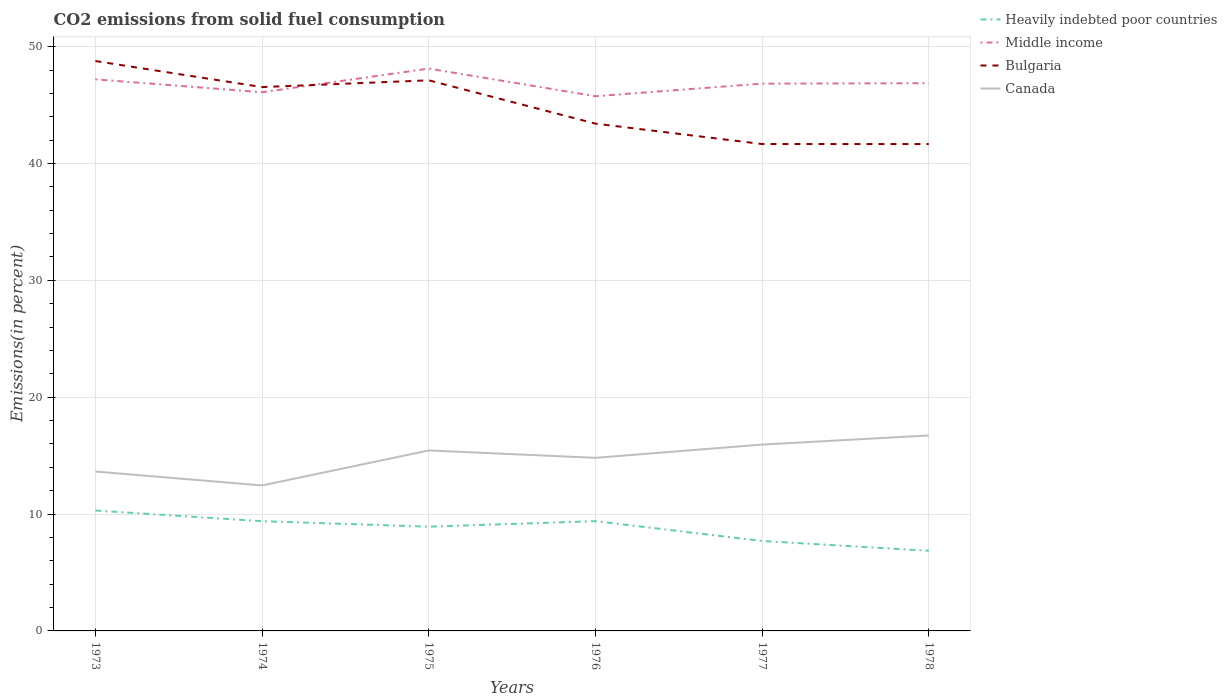How many different coloured lines are there?
Provide a succinct answer. 4. Does the line corresponding to Bulgaria intersect with the line corresponding to Canada?
Offer a very short reply. No. Is the number of lines equal to the number of legend labels?
Provide a succinct answer. Yes. Across all years, what is the maximum total CO2 emitted in Canada?
Offer a terse response. 12.45. In which year was the total CO2 emitted in Heavily indebted poor countries maximum?
Provide a short and direct response. 1978. What is the total total CO2 emitted in Bulgaria in the graph?
Make the answer very short. 5.35. What is the difference between the highest and the second highest total CO2 emitted in Canada?
Give a very brief answer. 4.28. How many years are there in the graph?
Ensure brevity in your answer.  6. What is the difference between two consecutive major ticks on the Y-axis?
Give a very brief answer. 10. Are the values on the major ticks of Y-axis written in scientific E-notation?
Keep it short and to the point. No. How many legend labels are there?
Offer a terse response. 4. How are the legend labels stacked?
Offer a very short reply. Vertical. What is the title of the graph?
Ensure brevity in your answer.  CO2 emissions from solid fuel consumption. Does "Thailand" appear as one of the legend labels in the graph?
Your response must be concise. No. What is the label or title of the Y-axis?
Provide a short and direct response. Emissions(in percent). What is the Emissions(in percent) in Heavily indebted poor countries in 1973?
Provide a succinct answer. 10.31. What is the Emissions(in percent) in Middle income in 1973?
Offer a very short reply. 47.2. What is the Emissions(in percent) in Bulgaria in 1973?
Keep it short and to the point. 48.77. What is the Emissions(in percent) of Canada in 1973?
Ensure brevity in your answer.  13.64. What is the Emissions(in percent) in Heavily indebted poor countries in 1974?
Your answer should be very brief. 9.39. What is the Emissions(in percent) of Middle income in 1974?
Make the answer very short. 46.1. What is the Emissions(in percent) in Bulgaria in 1974?
Your response must be concise. 46.54. What is the Emissions(in percent) of Canada in 1974?
Make the answer very short. 12.45. What is the Emissions(in percent) of Heavily indebted poor countries in 1975?
Provide a short and direct response. 8.92. What is the Emissions(in percent) in Middle income in 1975?
Provide a succinct answer. 48.12. What is the Emissions(in percent) in Bulgaria in 1975?
Keep it short and to the point. 47.12. What is the Emissions(in percent) in Canada in 1975?
Keep it short and to the point. 15.44. What is the Emissions(in percent) in Heavily indebted poor countries in 1976?
Your answer should be compact. 9.39. What is the Emissions(in percent) of Middle income in 1976?
Provide a short and direct response. 45.76. What is the Emissions(in percent) of Bulgaria in 1976?
Ensure brevity in your answer.  43.41. What is the Emissions(in percent) of Canada in 1976?
Offer a terse response. 14.81. What is the Emissions(in percent) of Heavily indebted poor countries in 1977?
Ensure brevity in your answer.  7.7. What is the Emissions(in percent) in Middle income in 1977?
Offer a very short reply. 46.83. What is the Emissions(in percent) of Bulgaria in 1977?
Your answer should be very brief. 41.67. What is the Emissions(in percent) in Canada in 1977?
Keep it short and to the point. 15.95. What is the Emissions(in percent) in Heavily indebted poor countries in 1978?
Provide a short and direct response. 6.86. What is the Emissions(in percent) in Middle income in 1978?
Provide a short and direct response. 46.87. What is the Emissions(in percent) in Bulgaria in 1978?
Your answer should be very brief. 41.66. What is the Emissions(in percent) of Canada in 1978?
Provide a short and direct response. 16.73. Across all years, what is the maximum Emissions(in percent) in Heavily indebted poor countries?
Ensure brevity in your answer.  10.31. Across all years, what is the maximum Emissions(in percent) of Middle income?
Make the answer very short. 48.12. Across all years, what is the maximum Emissions(in percent) of Bulgaria?
Ensure brevity in your answer.  48.77. Across all years, what is the maximum Emissions(in percent) of Canada?
Provide a succinct answer. 16.73. Across all years, what is the minimum Emissions(in percent) in Heavily indebted poor countries?
Your answer should be compact. 6.86. Across all years, what is the minimum Emissions(in percent) in Middle income?
Provide a short and direct response. 45.76. Across all years, what is the minimum Emissions(in percent) of Bulgaria?
Give a very brief answer. 41.66. Across all years, what is the minimum Emissions(in percent) of Canada?
Your response must be concise. 12.45. What is the total Emissions(in percent) in Heavily indebted poor countries in the graph?
Your response must be concise. 52.57. What is the total Emissions(in percent) of Middle income in the graph?
Make the answer very short. 280.89. What is the total Emissions(in percent) in Bulgaria in the graph?
Offer a very short reply. 269.17. What is the total Emissions(in percent) of Canada in the graph?
Offer a terse response. 89.02. What is the difference between the Emissions(in percent) in Heavily indebted poor countries in 1973 and that in 1974?
Your answer should be compact. 0.91. What is the difference between the Emissions(in percent) in Middle income in 1973 and that in 1974?
Make the answer very short. 1.1. What is the difference between the Emissions(in percent) of Bulgaria in 1973 and that in 1974?
Offer a very short reply. 2.23. What is the difference between the Emissions(in percent) in Canada in 1973 and that in 1974?
Make the answer very short. 1.19. What is the difference between the Emissions(in percent) in Heavily indebted poor countries in 1973 and that in 1975?
Offer a very short reply. 1.38. What is the difference between the Emissions(in percent) in Middle income in 1973 and that in 1975?
Make the answer very short. -0.92. What is the difference between the Emissions(in percent) in Bulgaria in 1973 and that in 1975?
Give a very brief answer. 1.65. What is the difference between the Emissions(in percent) of Canada in 1973 and that in 1975?
Provide a short and direct response. -1.8. What is the difference between the Emissions(in percent) of Heavily indebted poor countries in 1973 and that in 1976?
Provide a succinct answer. 0.91. What is the difference between the Emissions(in percent) of Middle income in 1973 and that in 1976?
Your response must be concise. 1.44. What is the difference between the Emissions(in percent) in Bulgaria in 1973 and that in 1976?
Offer a terse response. 5.35. What is the difference between the Emissions(in percent) of Canada in 1973 and that in 1976?
Your answer should be very brief. -1.17. What is the difference between the Emissions(in percent) of Heavily indebted poor countries in 1973 and that in 1977?
Provide a short and direct response. 2.61. What is the difference between the Emissions(in percent) in Middle income in 1973 and that in 1977?
Offer a terse response. 0.37. What is the difference between the Emissions(in percent) in Bulgaria in 1973 and that in 1977?
Give a very brief answer. 7.1. What is the difference between the Emissions(in percent) of Canada in 1973 and that in 1977?
Provide a short and direct response. -2.31. What is the difference between the Emissions(in percent) of Heavily indebted poor countries in 1973 and that in 1978?
Provide a short and direct response. 3.45. What is the difference between the Emissions(in percent) in Middle income in 1973 and that in 1978?
Keep it short and to the point. 0.33. What is the difference between the Emissions(in percent) of Bulgaria in 1973 and that in 1978?
Make the answer very short. 7.1. What is the difference between the Emissions(in percent) in Canada in 1973 and that in 1978?
Ensure brevity in your answer.  -3.09. What is the difference between the Emissions(in percent) in Heavily indebted poor countries in 1974 and that in 1975?
Keep it short and to the point. 0.47. What is the difference between the Emissions(in percent) of Middle income in 1974 and that in 1975?
Give a very brief answer. -2.02. What is the difference between the Emissions(in percent) of Bulgaria in 1974 and that in 1975?
Ensure brevity in your answer.  -0.58. What is the difference between the Emissions(in percent) of Canada in 1974 and that in 1975?
Your answer should be very brief. -2.99. What is the difference between the Emissions(in percent) in Heavily indebted poor countries in 1974 and that in 1976?
Your answer should be compact. -0. What is the difference between the Emissions(in percent) in Middle income in 1974 and that in 1976?
Keep it short and to the point. 0.34. What is the difference between the Emissions(in percent) of Bulgaria in 1974 and that in 1976?
Ensure brevity in your answer.  3.13. What is the difference between the Emissions(in percent) of Canada in 1974 and that in 1976?
Make the answer very short. -2.36. What is the difference between the Emissions(in percent) in Heavily indebted poor countries in 1974 and that in 1977?
Provide a succinct answer. 1.69. What is the difference between the Emissions(in percent) in Middle income in 1974 and that in 1977?
Keep it short and to the point. -0.74. What is the difference between the Emissions(in percent) of Bulgaria in 1974 and that in 1977?
Offer a terse response. 4.87. What is the difference between the Emissions(in percent) in Canada in 1974 and that in 1977?
Keep it short and to the point. -3.5. What is the difference between the Emissions(in percent) in Heavily indebted poor countries in 1974 and that in 1978?
Provide a succinct answer. 2.53. What is the difference between the Emissions(in percent) of Middle income in 1974 and that in 1978?
Offer a very short reply. -0.77. What is the difference between the Emissions(in percent) in Bulgaria in 1974 and that in 1978?
Make the answer very short. 4.87. What is the difference between the Emissions(in percent) in Canada in 1974 and that in 1978?
Provide a short and direct response. -4.28. What is the difference between the Emissions(in percent) of Heavily indebted poor countries in 1975 and that in 1976?
Give a very brief answer. -0.47. What is the difference between the Emissions(in percent) in Middle income in 1975 and that in 1976?
Make the answer very short. 2.37. What is the difference between the Emissions(in percent) of Bulgaria in 1975 and that in 1976?
Offer a very short reply. 3.71. What is the difference between the Emissions(in percent) of Canada in 1975 and that in 1976?
Keep it short and to the point. 0.63. What is the difference between the Emissions(in percent) in Heavily indebted poor countries in 1975 and that in 1977?
Keep it short and to the point. 1.22. What is the difference between the Emissions(in percent) in Middle income in 1975 and that in 1977?
Your answer should be compact. 1.29. What is the difference between the Emissions(in percent) of Bulgaria in 1975 and that in 1977?
Give a very brief answer. 5.45. What is the difference between the Emissions(in percent) of Canada in 1975 and that in 1977?
Keep it short and to the point. -0.5. What is the difference between the Emissions(in percent) in Heavily indebted poor countries in 1975 and that in 1978?
Provide a succinct answer. 2.06. What is the difference between the Emissions(in percent) of Middle income in 1975 and that in 1978?
Your response must be concise. 1.25. What is the difference between the Emissions(in percent) in Bulgaria in 1975 and that in 1978?
Offer a very short reply. 5.45. What is the difference between the Emissions(in percent) in Canada in 1975 and that in 1978?
Give a very brief answer. -1.28. What is the difference between the Emissions(in percent) in Heavily indebted poor countries in 1976 and that in 1977?
Offer a very short reply. 1.7. What is the difference between the Emissions(in percent) of Middle income in 1976 and that in 1977?
Your answer should be very brief. -1.08. What is the difference between the Emissions(in percent) of Bulgaria in 1976 and that in 1977?
Your response must be concise. 1.75. What is the difference between the Emissions(in percent) in Canada in 1976 and that in 1977?
Offer a terse response. -1.13. What is the difference between the Emissions(in percent) of Heavily indebted poor countries in 1976 and that in 1978?
Offer a very short reply. 2.54. What is the difference between the Emissions(in percent) in Middle income in 1976 and that in 1978?
Your answer should be very brief. -1.11. What is the difference between the Emissions(in percent) of Bulgaria in 1976 and that in 1978?
Make the answer very short. 1.75. What is the difference between the Emissions(in percent) of Canada in 1976 and that in 1978?
Provide a short and direct response. -1.91. What is the difference between the Emissions(in percent) in Heavily indebted poor countries in 1977 and that in 1978?
Your answer should be compact. 0.84. What is the difference between the Emissions(in percent) of Middle income in 1977 and that in 1978?
Your answer should be very brief. -0.04. What is the difference between the Emissions(in percent) of Bulgaria in 1977 and that in 1978?
Keep it short and to the point. 0. What is the difference between the Emissions(in percent) of Canada in 1977 and that in 1978?
Your response must be concise. -0.78. What is the difference between the Emissions(in percent) of Heavily indebted poor countries in 1973 and the Emissions(in percent) of Middle income in 1974?
Give a very brief answer. -35.79. What is the difference between the Emissions(in percent) of Heavily indebted poor countries in 1973 and the Emissions(in percent) of Bulgaria in 1974?
Keep it short and to the point. -36.23. What is the difference between the Emissions(in percent) of Heavily indebted poor countries in 1973 and the Emissions(in percent) of Canada in 1974?
Provide a succinct answer. -2.14. What is the difference between the Emissions(in percent) of Middle income in 1973 and the Emissions(in percent) of Bulgaria in 1974?
Keep it short and to the point. 0.66. What is the difference between the Emissions(in percent) of Middle income in 1973 and the Emissions(in percent) of Canada in 1974?
Your answer should be very brief. 34.75. What is the difference between the Emissions(in percent) in Bulgaria in 1973 and the Emissions(in percent) in Canada in 1974?
Keep it short and to the point. 36.32. What is the difference between the Emissions(in percent) in Heavily indebted poor countries in 1973 and the Emissions(in percent) in Middle income in 1975?
Offer a terse response. -37.82. What is the difference between the Emissions(in percent) of Heavily indebted poor countries in 1973 and the Emissions(in percent) of Bulgaria in 1975?
Your response must be concise. -36.81. What is the difference between the Emissions(in percent) of Heavily indebted poor countries in 1973 and the Emissions(in percent) of Canada in 1975?
Provide a succinct answer. -5.14. What is the difference between the Emissions(in percent) of Middle income in 1973 and the Emissions(in percent) of Bulgaria in 1975?
Provide a succinct answer. 0.08. What is the difference between the Emissions(in percent) of Middle income in 1973 and the Emissions(in percent) of Canada in 1975?
Your answer should be compact. 31.76. What is the difference between the Emissions(in percent) in Bulgaria in 1973 and the Emissions(in percent) in Canada in 1975?
Give a very brief answer. 33.32. What is the difference between the Emissions(in percent) in Heavily indebted poor countries in 1973 and the Emissions(in percent) in Middle income in 1976?
Offer a very short reply. -35.45. What is the difference between the Emissions(in percent) in Heavily indebted poor countries in 1973 and the Emissions(in percent) in Bulgaria in 1976?
Provide a short and direct response. -33.11. What is the difference between the Emissions(in percent) in Heavily indebted poor countries in 1973 and the Emissions(in percent) in Canada in 1976?
Make the answer very short. -4.51. What is the difference between the Emissions(in percent) in Middle income in 1973 and the Emissions(in percent) in Bulgaria in 1976?
Keep it short and to the point. 3.79. What is the difference between the Emissions(in percent) of Middle income in 1973 and the Emissions(in percent) of Canada in 1976?
Offer a very short reply. 32.39. What is the difference between the Emissions(in percent) of Bulgaria in 1973 and the Emissions(in percent) of Canada in 1976?
Offer a very short reply. 33.95. What is the difference between the Emissions(in percent) in Heavily indebted poor countries in 1973 and the Emissions(in percent) in Middle income in 1977?
Provide a succinct answer. -36.53. What is the difference between the Emissions(in percent) of Heavily indebted poor countries in 1973 and the Emissions(in percent) of Bulgaria in 1977?
Ensure brevity in your answer.  -31.36. What is the difference between the Emissions(in percent) in Heavily indebted poor countries in 1973 and the Emissions(in percent) in Canada in 1977?
Your answer should be very brief. -5.64. What is the difference between the Emissions(in percent) of Middle income in 1973 and the Emissions(in percent) of Bulgaria in 1977?
Provide a short and direct response. 5.54. What is the difference between the Emissions(in percent) in Middle income in 1973 and the Emissions(in percent) in Canada in 1977?
Keep it short and to the point. 31.26. What is the difference between the Emissions(in percent) in Bulgaria in 1973 and the Emissions(in percent) in Canada in 1977?
Offer a terse response. 32.82. What is the difference between the Emissions(in percent) in Heavily indebted poor countries in 1973 and the Emissions(in percent) in Middle income in 1978?
Keep it short and to the point. -36.57. What is the difference between the Emissions(in percent) in Heavily indebted poor countries in 1973 and the Emissions(in percent) in Bulgaria in 1978?
Make the answer very short. -31.36. What is the difference between the Emissions(in percent) in Heavily indebted poor countries in 1973 and the Emissions(in percent) in Canada in 1978?
Offer a terse response. -6.42. What is the difference between the Emissions(in percent) of Middle income in 1973 and the Emissions(in percent) of Bulgaria in 1978?
Make the answer very short. 5.54. What is the difference between the Emissions(in percent) in Middle income in 1973 and the Emissions(in percent) in Canada in 1978?
Your answer should be compact. 30.48. What is the difference between the Emissions(in percent) of Bulgaria in 1973 and the Emissions(in percent) of Canada in 1978?
Your response must be concise. 32.04. What is the difference between the Emissions(in percent) in Heavily indebted poor countries in 1974 and the Emissions(in percent) in Middle income in 1975?
Offer a terse response. -38.73. What is the difference between the Emissions(in percent) in Heavily indebted poor countries in 1974 and the Emissions(in percent) in Bulgaria in 1975?
Your answer should be compact. -37.73. What is the difference between the Emissions(in percent) of Heavily indebted poor countries in 1974 and the Emissions(in percent) of Canada in 1975?
Provide a succinct answer. -6.05. What is the difference between the Emissions(in percent) of Middle income in 1974 and the Emissions(in percent) of Bulgaria in 1975?
Provide a succinct answer. -1.02. What is the difference between the Emissions(in percent) in Middle income in 1974 and the Emissions(in percent) in Canada in 1975?
Ensure brevity in your answer.  30.66. What is the difference between the Emissions(in percent) in Bulgaria in 1974 and the Emissions(in percent) in Canada in 1975?
Your answer should be compact. 31.1. What is the difference between the Emissions(in percent) of Heavily indebted poor countries in 1974 and the Emissions(in percent) of Middle income in 1976?
Your answer should be compact. -36.37. What is the difference between the Emissions(in percent) in Heavily indebted poor countries in 1974 and the Emissions(in percent) in Bulgaria in 1976?
Your response must be concise. -34.02. What is the difference between the Emissions(in percent) in Heavily indebted poor countries in 1974 and the Emissions(in percent) in Canada in 1976?
Give a very brief answer. -5.42. What is the difference between the Emissions(in percent) in Middle income in 1974 and the Emissions(in percent) in Bulgaria in 1976?
Your response must be concise. 2.69. What is the difference between the Emissions(in percent) in Middle income in 1974 and the Emissions(in percent) in Canada in 1976?
Your response must be concise. 31.29. What is the difference between the Emissions(in percent) of Bulgaria in 1974 and the Emissions(in percent) of Canada in 1976?
Offer a terse response. 31.73. What is the difference between the Emissions(in percent) of Heavily indebted poor countries in 1974 and the Emissions(in percent) of Middle income in 1977?
Provide a succinct answer. -37.44. What is the difference between the Emissions(in percent) of Heavily indebted poor countries in 1974 and the Emissions(in percent) of Bulgaria in 1977?
Your answer should be very brief. -32.28. What is the difference between the Emissions(in percent) of Heavily indebted poor countries in 1974 and the Emissions(in percent) of Canada in 1977?
Your answer should be very brief. -6.56. What is the difference between the Emissions(in percent) in Middle income in 1974 and the Emissions(in percent) in Bulgaria in 1977?
Your response must be concise. 4.43. What is the difference between the Emissions(in percent) in Middle income in 1974 and the Emissions(in percent) in Canada in 1977?
Provide a succinct answer. 30.15. What is the difference between the Emissions(in percent) of Bulgaria in 1974 and the Emissions(in percent) of Canada in 1977?
Offer a terse response. 30.59. What is the difference between the Emissions(in percent) of Heavily indebted poor countries in 1974 and the Emissions(in percent) of Middle income in 1978?
Offer a very short reply. -37.48. What is the difference between the Emissions(in percent) in Heavily indebted poor countries in 1974 and the Emissions(in percent) in Bulgaria in 1978?
Give a very brief answer. -32.27. What is the difference between the Emissions(in percent) of Heavily indebted poor countries in 1974 and the Emissions(in percent) of Canada in 1978?
Provide a succinct answer. -7.34. What is the difference between the Emissions(in percent) of Middle income in 1974 and the Emissions(in percent) of Bulgaria in 1978?
Offer a very short reply. 4.43. What is the difference between the Emissions(in percent) of Middle income in 1974 and the Emissions(in percent) of Canada in 1978?
Provide a short and direct response. 29.37. What is the difference between the Emissions(in percent) in Bulgaria in 1974 and the Emissions(in percent) in Canada in 1978?
Your answer should be compact. 29.81. What is the difference between the Emissions(in percent) of Heavily indebted poor countries in 1975 and the Emissions(in percent) of Middle income in 1976?
Your response must be concise. -36.84. What is the difference between the Emissions(in percent) in Heavily indebted poor countries in 1975 and the Emissions(in percent) in Bulgaria in 1976?
Offer a very short reply. -34.49. What is the difference between the Emissions(in percent) of Heavily indebted poor countries in 1975 and the Emissions(in percent) of Canada in 1976?
Give a very brief answer. -5.89. What is the difference between the Emissions(in percent) of Middle income in 1975 and the Emissions(in percent) of Bulgaria in 1976?
Your answer should be very brief. 4.71. What is the difference between the Emissions(in percent) of Middle income in 1975 and the Emissions(in percent) of Canada in 1976?
Your response must be concise. 33.31. What is the difference between the Emissions(in percent) in Bulgaria in 1975 and the Emissions(in percent) in Canada in 1976?
Provide a succinct answer. 32.31. What is the difference between the Emissions(in percent) of Heavily indebted poor countries in 1975 and the Emissions(in percent) of Middle income in 1977?
Offer a very short reply. -37.91. What is the difference between the Emissions(in percent) in Heavily indebted poor countries in 1975 and the Emissions(in percent) in Bulgaria in 1977?
Offer a terse response. -32.74. What is the difference between the Emissions(in percent) of Heavily indebted poor countries in 1975 and the Emissions(in percent) of Canada in 1977?
Offer a terse response. -7.03. What is the difference between the Emissions(in percent) of Middle income in 1975 and the Emissions(in percent) of Bulgaria in 1977?
Provide a short and direct response. 6.46. What is the difference between the Emissions(in percent) in Middle income in 1975 and the Emissions(in percent) in Canada in 1977?
Offer a terse response. 32.18. What is the difference between the Emissions(in percent) of Bulgaria in 1975 and the Emissions(in percent) of Canada in 1977?
Keep it short and to the point. 31.17. What is the difference between the Emissions(in percent) of Heavily indebted poor countries in 1975 and the Emissions(in percent) of Middle income in 1978?
Make the answer very short. -37.95. What is the difference between the Emissions(in percent) in Heavily indebted poor countries in 1975 and the Emissions(in percent) in Bulgaria in 1978?
Your answer should be compact. -32.74. What is the difference between the Emissions(in percent) in Heavily indebted poor countries in 1975 and the Emissions(in percent) in Canada in 1978?
Give a very brief answer. -7.81. What is the difference between the Emissions(in percent) of Middle income in 1975 and the Emissions(in percent) of Bulgaria in 1978?
Your response must be concise. 6.46. What is the difference between the Emissions(in percent) of Middle income in 1975 and the Emissions(in percent) of Canada in 1978?
Your response must be concise. 31.4. What is the difference between the Emissions(in percent) in Bulgaria in 1975 and the Emissions(in percent) in Canada in 1978?
Offer a very short reply. 30.39. What is the difference between the Emissions(in percent) in Heavily indebted poor countries in 1976 and the Emissions(in percent) in Middle income in 1977?
Make the answer very short. -37.44. What is the difference between the Emissions(in percent) of Heavily indebted poor countries in 1976 and the Emissions(in percent) of Bulgaria in 1977?
Provide a succinct answer. -32.27. What is the difference between the Emissions(in percent) in Heavily indebted poor countries in 1976 and the Emissions(in percent) in Canada in 1977?
Keep it short and to the point. -6.55. What is the difference between the Emissions(in percent) of Middle income in 1976 and the Emissions(in percent) of Bulgaria in 1977?
Offer a terse response. 4.09. What is the difference between the Emissions(in percent) in Middle income in 1976 and the Emissions(in percent) in Canada in 1977?
Your answer should be compact. 29.81. What is the difference between the Emissions(in percent) of Bulgaria in 1976 and the Emissions(in percent) of Canada in 1977?
Your response must be concise. 27.47. What is the difference between the Emissions(in percent) of Heavily indebted poor countries in 1976 and the Emissions(in percent) of Middle income in 1978?
Ensure brevity in your answer.  -37.48. What is the difference between the Emissions(in percent) in Heavily indebted poor countries in 1976 and the Emissions(in percent) in Bulgaria in 1978?
Your answer should be very brief. -32.27. What is the difference between the Emissions(in percent) in Heavily indebted poor countries in 1976 and the Emissions(in percent) in Canada in 1978?
Your answer should be compact. -7.33. What is the difference between the Emissions(in percent) in Middle income in 1976 and the Emissions(in percent) in Bulgaria in 1978?
Ensure brevity in your answer.  4.09. What is the difference between the Emissions(in percent) of Middle income in 1976 and the Emissions(in percent) of Canada in 1978?
Provide a succinct answer. 29.03. What is the difference between the Emissions(in percent) of Bulgaria in 1976 and the Emissions(in percent) of Canada in 1978?
Your response must be concise. 26.69. What is the difference between the Emissions(in percent) of Heavily indebted poor countries in 1977 and the Emissions(in percent) of Middle income in 1978?
Your response must be concise. -39.17. What is the difference between the Emissions(in percent) of Heavily indebted poor countries in 1977 and the Emissions(in percent) of Bulgaria in 1978?
Keep it short and to the point. -33.97. What is the difference between the Emissions(in percent) in Heavily indebted poor countries in 1977 and the Emissions(in percent) in Canada in 1978?
Give a very brief answer. -9.03. What is the difference between the Emissions(in percent) in Middle income in 1977 and the Emissions(in percent) in Bulgaria in 1978?
Keep it short and to the point. 5.17. What is the difference between the Emissions(in percent) of Middle income in 1977 and the Emissions(in percent) of Canada in 1978?
Provide a succinct answer. 30.11. What is the difference between the Emissions(in percent) in Bulgaria in 1977 and the Emissions(in percent) in Canada in 1978?
Keep it short and to the point. 24.94. What is the average Emissions(in percent) in Heavily indebted poor countries per year?
Your answer should be compact. 8.76. What is the average Emissions(in percent) in Middle income per year?
Offer a terse response. 46.81. What is the average Emissions(in percent) of Bulgaria per year?
Give a very brief answer. 44.86. What is the average Emissions(in percent) of Canada per year?
Offer a very short reply. 14.84. In the year 1973, what is the difference between the Emissions(in percent) of Heavily indebted poor countries and Emissions(in percent) of Middle income?
Offer a very short reply. -36.9. In the year 1973, what is the difference between the Emissions(in percent) of Heavily indebted poor countries and Emissions(in percent) of Bulgaria?
Provide a short and direct response. -38.46. In the year 1973, what is the difference between the Emissions(in percent) of Heavily indebted poor countries and Emissions(in percent) of Canada?
Offer a terse response. -3.34. In the year 1973, what is the difference between the Emissions(in percent) in Middle income and Emissions(in percent) in Bulgaria?
Your answer should be compact. -1.56. In the year 1973, what is the difference between the Emissions(in percent) of Middle income and Emissions(in percent) of Canada?
Keep it short and to the point. 33.56. In the year 1973, what is the difference between the Emissions(in percent) in Bulgaria and Emissions(in percent) in Canada?
Make the answer very short. 35.13. In the year 1974, what is the difference between the Emissions(in percent) in Heavily indebted poor countries and Emissions(in percent) in Middle income?
Provide a succinct answer. -36.71. In the year 1974, what is the difference between the Emissions(in percent) in Heavily indebted poor countries and Emissions(in percent) in Bulgaria?
Offer a very short reply. -37.15. In the year 1974, what is the difference between the Emissions(in percent) of Heavily indebted poor countries and Emissions(in percent) of Canada?
Your answer should be compact. -3.06. In the year 1974, what is the difference between the Emissions(in percent) of Middle income and Emissions(in percent) of Bulgaria?
Give a very brief answer. -0.44. In the year 1974, what is the difference between the Emissions(in percent) of Middle income and Emissions(in percent) of Canada?
Give a very brief answer. 33.65. In the year 1974, what is the difference between the Emissions(in percent) of Bulgaria and Emissions(in percent) of Canada?
Keep it short and to the point. 34.09. In the year 1975, what is the difference between the Emissions(in percent) in Heavily indebted poor countries and Emissions(in percent) in Middle income?
Offer a terse response. -39.2. In the year 1975, what is the difference between the Emissions(in percent) in Heavily indebted poor countries and Emissions(in percent) in Bulgaria?
Give a very brief answer. -38.2. In the year 1975, what is the difference between the Emissions(in percent) in Heavily indebted poor countries and Emissions(in percent) in Canada?
Ensure brevity in your answer.  -6.52. In the year 1975, what is the difference between the Emissions(in percent) of Middle income and Emissions(in percent) of Bulgaria?
Ensure brevity in your answer.  1. In the year 1975, what is the difference between the Emissions(in percent) of Middle income and Emissions(in percent) of Canada?
Your answer should be compact. 32.68. In the year 1975, what is the difference between the Emissions(in percent) in Bulgaria and Emissions(in percent) in Canada?
Offer a very short reply. 31.68. In the year 1976, what is the difference between the Emissions(in percent) in Heavily indebted poor countries and Emissions(in percent) in Middle income?
Your response must be concise. -36.36. In the year 1976, what is the difference between the Emissions(in percent) in Heavily indebted poor countries and Emissions(in percent) in Bulgaria?
Offer a very short reply. -34.02. In the year 1976, what is the difference between the Emissions(in percent) in Heavily indebted poor countries and Emissions(in percent) in Canada?
Ensure brevity in your answer.  -5.42. In the year 1976, what is the difference between the Emissions(in percent) in Middle income and Emissions(in percent) in Bulgaria?
Ensure brevity in your answer.  2.35. In the year 1976, what is the difference between the Emissions(in percent) of Middle income and Emissions(in percent) of Canada?
Provide a succinct answer. 30.95. In the year 1976, what is the difference between the Emissions(in percent) in Bulgaria and Emissions(in percent) in Canada?
Give a very brief answer. 28.6. In the year 1977, what is the difference between the Emissions(in percent) in Heavily indebted poor countries and Emissions(in percent) in Middle income?
Provide a short and direct response. -39.14. In the year 1977, what is the difference between the Emissions(in percent) in Heavily indebted poor countries and Emissions(in percent) in Bulgaria?
Offer a terse response. -33.97. In the year 1977, what is the difference between the Emissions(in percent) of Heavily indebted poor countries and Emissions(in percent) of Canada?
Keep it short and to the point. -8.25. In the year 1977, what is the difference between the Emissions(in percent) in Middle income and Emissions(in percent) in Bulgaria?
Provide a succinct answer. 5.17. In the year 1977, what is the difference between the Emissions(in percent) of Middle income and Emissions(in percent) of Canada?
Provide a short and direct response. 30.89. In the year 1977, what is the difference between the Emissions(in percent) in Bulgaria and Emissions(in percent) in Canada?
Provide a succinct answer. 25.72. In the year 1978, what is the difference between the Emissions(in percent) of Heavily indebted poor countries and Emissions(in percent) of Middle income?
Keep it short and to the point. -40.01. In the year 1978, what is the difference between the Emissions(in percent) in Heavily indebted poor countries and Emissions(in percent) in Bulgaria?
Offer a very short reply. -34.81. In the year 1978, what is the difference between the Emissions(in percent) of Heavily indebted poor countries and Emissions(in percent) of Canada?
Your response must be concise. -9.87. In the year 1978, what is the difference between the Emissions(in percent) in Middle income and Emissions(in percent) in Bulgaria?
Keep it short and to the point. 5.21. In the year 1978, what is the difference between the Emissions(in percent) of Middle income and Emissions(in percent) of Canada?
Give a very brief answer. 30.14. In the year 1978, what is the difference between the Emissions(in percent) of Bulgaria and Emissions(in percent) of Canada?
Make the answer very short. 24.94. What is the ratio of the Emissions(in percent) of Heavily indebted poor countries in 1973 to that in 1974?
Keep it short and to the point. 1.1. What is the ratio of the Emissions(in percent) in Middle income in 1973 to that in 1974?
Offer a very short reply. 1.02. What is the ratio of the Emissions(in percent) in Bulgaria in 1973 to that in 1974?
Keep it short and to the point. 1.05. What is the ratio of the Emissions(in percent) of Canada in 1973 to that in 1974?
Your answer should be compact. 1.1. What is the ratio of the Emissions(in percent) of Heavily indebted poor countries in 1973 to that in 1975?
Provide a succinct answer. 1.16. What is the ratio of the Emissions(in percent) in Middle income in 1973 to that in 1975?
Your response must be concise. 0.98. What is the ratio of the Emissions(in percent) in Bulgaria in 1973 to that in 1975?
Provide a short and direct response. 1.03. What is the ratio of the Emissions(in percent) in Canada in 1973 to that in 1975?
Provide a succinct answer. 0.88. What is the ratio of the Emissions(in percent) of Heavily indebted poor countries in 1973 to that in 1976?
Make the answer very short. 1.1. What is the ratio of the Emissions(in percent) in Middle income in 1973 to that in 1976?
Your answer should be very brief. 1.03. What is the ratio of the Emissions(in percent) in Bulgaria in 1973 to that in 1976?
Your answer should be compact. 1.12. What is the ratio of the Emissions(in percent) of Canada in 1973 to that in 1976?
Your answer should be compact. 0.92. What is the ratio of the Emissions(in percent) in Heavily indebted poor countries in 1973 to that in 1977?
Provide a short and direct response. 1.34. What is the ratio of the Emissions(in percent) in Middle income in 1973 to that in 1977?
Provide a short and direct response. 1.01. What is the ratio of the Emissions(in percent) in Bulgaria in 1973 to that in 1977?
Give a very brief answer. 1.17. What is the ratio of the Emissions(in percent) in Canada in 1973 to that in 1977?
Your answer should be compact. 0.86. What is the ratio of the Emissions(in percent) of Heavily indebted poor countries in 1973 to that in 1978?
Offer a terse response. 1.5. What is the ratio of the Emissions(in percent) of Middle income in 1973 to that in 1978?
Provide a succinct answer. 1.01. What is the ratio of the Emissions(in percent) of Bulgaria in 1973 to that in 1978?
Provide a short and direct response. 1.17. What is the ratio of the Emissions(in percent) of Canada in 1973 to that in 1978?
Provide a succinct answer. 0.82. What is the ratio of the Emissions(in percent) of Heavily indebted poor countries in 1974 to that in 1975?
Provide a short and direct response. 1.05. What is the ratio of the Emissions(in percent) in Middle income in 1974 to that in 1975?
Offer a very short reply. 0.96. What is the ratio of the Emissions(in percent) in Bulgaria in 1974 to that in 1975?
Your response must be concise. 0.99. What is the ratio of the Emissions(in percent) in Canada in 1974 to that in 1975?
Your answer should be very brief. 0.81. What is the ratio of the Emissions(in percent) in Heavily indebted poor countries in 1974 to that in 1976?
Ensure brevity in your answer.  1. What is the ratio of the Emissions(in percent) in Middle income in 1974 to that in 1976?
Ensure brevity in your answer.  1.01. What is the ratio of the Emissions(in percent) of Bulgaria in 1974 to that in 1976?
Offer a terse response. 1.07. What is the ratio of the Emissions(in percent) of Canada in 1974 to that in 1976?
Provide a succinct answer. 0.84. What is the ratio of the Emissions(in percent) in Heavily indebted poor countries in 1974 to that in 1977?
Your answer should be very brief. 1.22. What is the ratio of the Emissions(in percent) of Middle income in 1974 to that in 1977?
Make the answer very short. 0.98. What is the ratio of the Emissions(in percent) of Bulgaria in 1974 to that in 1977?
Your response must be concise. 1.12. What is the ratio of the Emissions(in percent) in Canada in 1974 to that in 1977?
Offer a terse response. 0.78. What is the ratio of the Emissions(in percent) of Heavily indebted poor countries in 1974 to that in 1978?
Give a very brief answer. 1.37. What is the ratio of the Emissions(in percent) in Middle income in 1974 to that in 1978?
Your response must be concise. 0.98. What is the ratio of the Emissions(in percent) in Bulgaria in 1974 to that in 1978?
Keep it short and to the point. 1.12. What is the ratio of the Emissions(in percent) of Canada in 1974 to that in 1978?
Give a very brief answer. 0.74. What is the ratio of the Emissions(in percent) in Heavily indebted poor countries in 1975 to that in 1976?
Give a very brief answer. 0.95. What is the ratio of the Emissions(in percent) of Middle income in 1975 to that in 1976?
Offer a terse response. 1.05. What is the ratio of the Emissions(in percent) of Bulgaria in 1975 to that in 1976?
Provide a short and direct response. 1.09. What is the ratio of the Emissions(in percent) in Canada in 1975 to that in 1976?
Give a very brief answer. 1.04. What is the ratio of the Emissions(in percent) in Heavily indebted poor countries in 1975 to that in 1977?
Keep it short and to the point. 1.16. What is the ratio of the Emissions(in percent) of Middle income in 1975 to that in 1977?
Provide a succinct answer. 1.03. What is the ratio of the Emissions(in percent) of Bulgaria in 1975 to that in 1977?
Make the answer very short. 1.13. What is the ratio of the Emissions(in percent) of Canada in 1975 to that in 1977?
Your answer should be very brief. 0.97. What is the ratio of the Emissions(in percent) in Heavily indebted poor countries in 1975 to that in 1978?
Provide a short and direct response. 1.3. What is the ratio of the Emissions(in percent) of Middle income in 1975 to that in 1978?
Provide a short and direct response. 1.03. What is the ratio of the Emissions(in percent) of Bulgaria in 1975 to that in 1978?
Your answer should be compact. 1.13. What is the ratio of the Emissions(in percent) of Canada in 1975 to that in 1978?
Offer a very short reply. 0.92. What is the ratio of the Emissions(in percent) of Heavily indebted poor countries in 1976 to that in 1977?
Ensure brevity in your answer.  1.22. What is the ratio of the Emissions(in percent) of Bulgaria in 1976 to that in 1977?
Offer a terse response. 1.04. What is the ratio of the Emissions(in percent) in Canada in 1976 to that in 1977?
Give a very brief answer. 0.93. What is the ratio of the Emissions(in percent) in Heavily indebted poor countries in 1976 to that in 1978?
Offer a very short reply. 1.37. What is the ratio of the Emissions(in percent) in Middle income in 1976 to that in 1978?
Your answer should be compact. 0.98. What is the ratio of the Emissions(in percent) of Bulgaria in 1976 to that in 1978?
Your answer should be compact. 1.04. What is the ratio of the Emissions(in percent) of Canada in 1976 to that in 1978?
Your response must be concise. 0.89. What is the ratio of the Emissions(in percent) of Heavily indebted poor countries in 1977 to that in 1978?
Ensure brevity in your answer.  1.12. What is the ratio of the Emissions(in percent) of Middle income in 1977 to that in 1978?
Ensure brevity in your answer.  1. What is the ratio of the Emissions(in percent) of Bulgaria in 1977 to that in 1978?
Provide a succinct answer. 1. What is the ratio of the Emissions(in percent) in Canada in 1977 to that in 1978?
Make the answer very short. 0.95. What is the difference between the highest and the second highest Emissions(in percent) in Heavily indebted poor countries?
Keep it short and to the point. 0.91. What is the difference between the highest and the second highest Emissions(in percent) of Middle income?
Keep it short and to the point. 0.92. What is the difference between the highest and the second highest Emissions(in percent) of Bulgaria?
Your answer should be very brief. 1.65. What is the difference between the highest and the second highest Emissions(in percent) of Canada?
Your response must be concise. 0.78. What is the difference between the highest and the lowest Emissions(in percent) of Heavily indebted poor countries?
Ensure brevity in your answer.  3.45. What is the difference between the highest and the lowest Emissions(in percent) of Middle income?
Make the answer very short. 2.37. What is the difference between the highest and the lowest Emissions(in percent) in Bulgaria?
Make the answer very short. 7.1. What is the difference between the highest and the lowest Emissions(in percent) in Canada?
Provide a succinct answer. 4.28. 